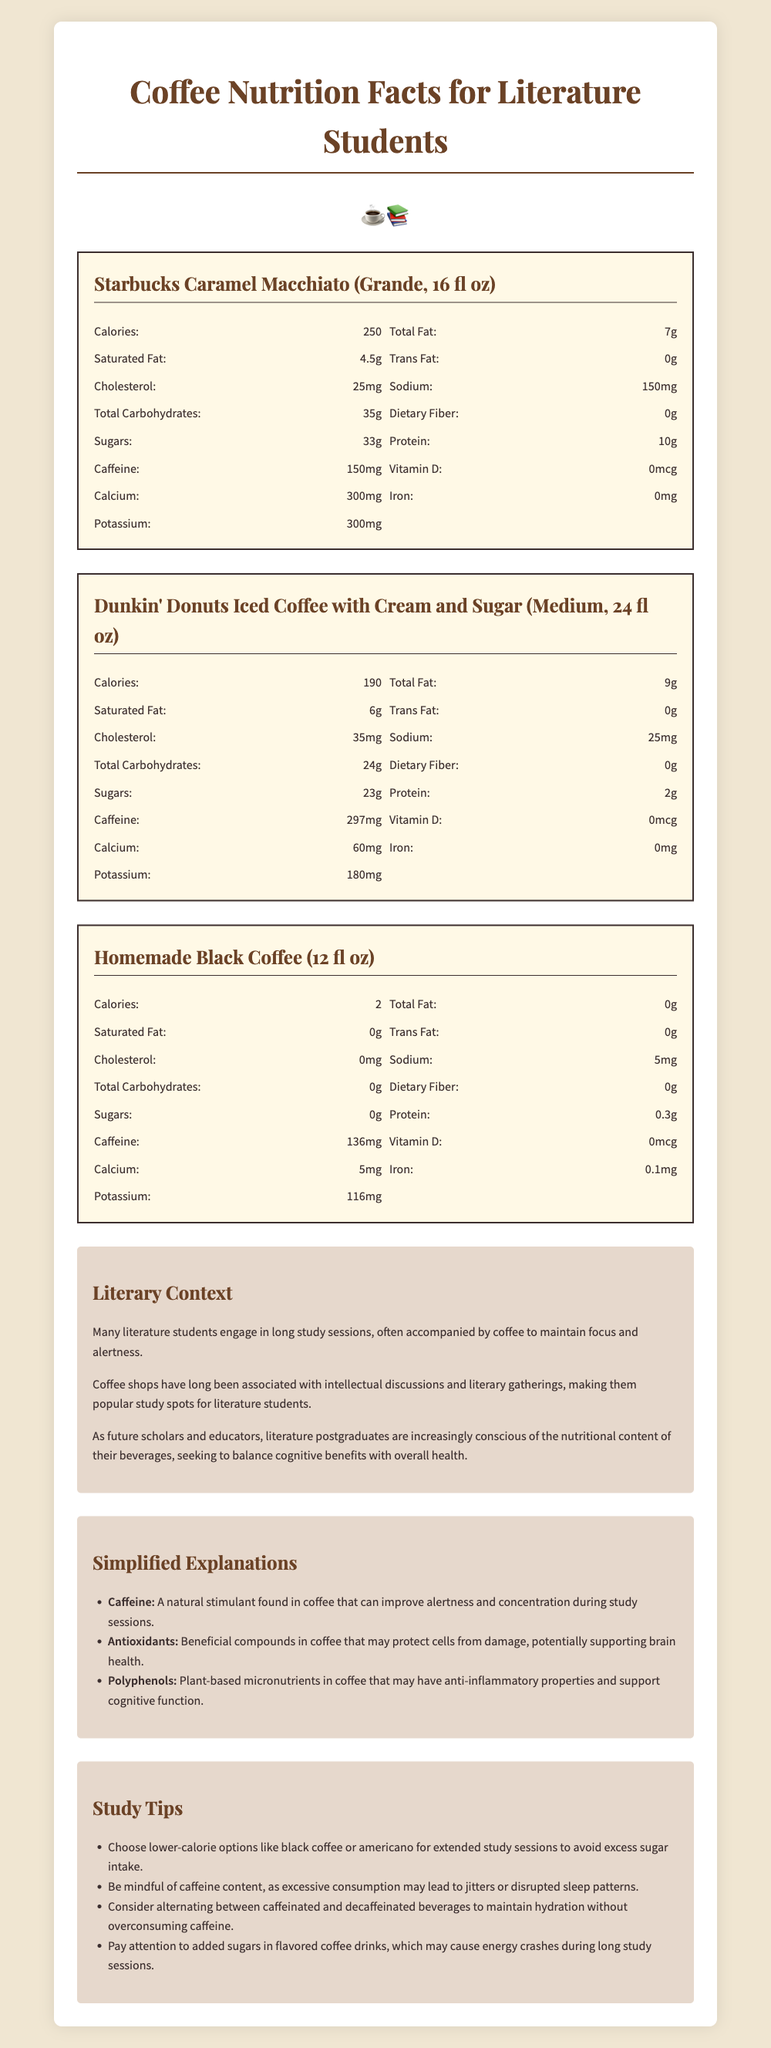what is the calorie content of a Homemade Black Coffee (12 fl oz)? The document states that Homemade Black Coffee contains 2 calories.
Answer: 2 calories which coffee has the highest sugar content? The document shows that Starbucks Caramel Macchiato has 33 grams of sugar, the highest among the options listed.
Answer: Starbucks Caramel Macchiato (Grande, 16 fl oz) how much protein does a Dunkin' Donuts Iced Coffee with Cream and Sugar (Medium, 24 fl oz) have? According to the document, Dunkin' Donuts Iced Coffee with Cream and Sugar contains 2 grams of protein.
Answer: 2 grams what is the main benefit of caffeine mentioned? The simplified explanations section states that caffeine is a natural stimulant that can improve alertness and concentration during study sessions.
Answer: Improve alertness and concentration what is one health-related reason literature postgraduates should be mindful of their beverage choices? The literary context section notes that literature postgraduates aim to balance the cognitive benefits of coffee with their overall health.
Answer: Balance cognitive benefits with overall health which coffee has the lowest sodium content?
A. Starbucks Caramel Macchiato (Grande, 16 fl oz)
B. Dunkin' Donuts Iced Coffee with Cream and Sugar (Medium, 24 fl oz)
C. Homemade Black Coffee (12 fl oz) The document shows that Homemade Black Coffee has 5 mg of sodium, the lowest among the listed options.
Answer: C which of the following contains the most caffeine?
I. Starbucks Caramel Macchiato (Grande, 16 fl oz)
II. Dunkin' Donuts Iced Coffee with Cream and Sugar (Medium, 24 fl oz)
III. Homemade Black Coffee (12 fl oz) The document indicates that Dunkin' Donuts Iced Coffee has 297 mg of caffeine, the highest amount listed.
Answer: II does Starbucks Caramel Macchiato contain any trans fat? The document specifies that Starbucks Caramel Macchiato contains 0 grams of trans fat.
Answer: No summarize the main idea of the document The document provides a detailed comparison of the nutritional content of different coffee drinks, aims to cater to literature students' study habits, and offers health-conscious study tips along with simplified explanations of key nutritional terms.
Answer: Comparison of nutritional content in popular coffee drinks and study tips for literature students how many milligrams of iron does each coffee contain? The document only specifies that Homemade Black Coffee contains 0.1 milligrams of iron, but does not provide sufficient comparative data for the other coffees.
Answer: Not enough information 